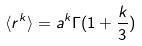<formula> <loc_0><loc_0><loc_500><loc_500>\langle r ^ { k } \rangle = a ^ { k } \Gamma ( 1 + \frac { k } { 3 } )</formula> 